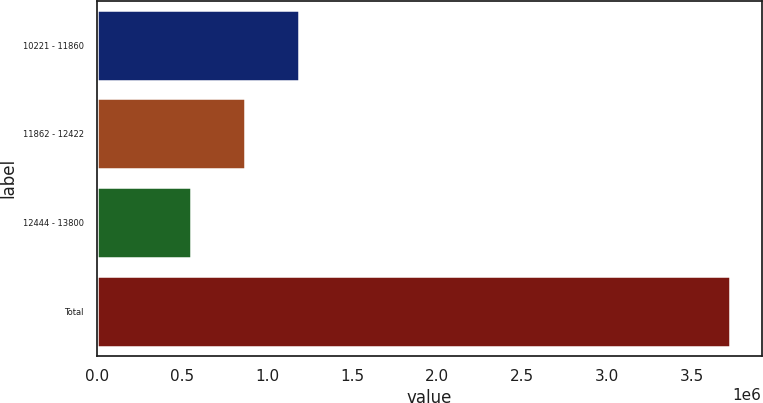<chart> <loc_0><loc_0><loc_500><loc_500><bar_chart><fcel>10221 - 11860<fcel>11862 - 12422<fcel>12444 - 13800<fcel>Total<nl><fcel>1.18681e+06<fcel>869637<fcel>552466<fcel>3.72418e+06<nl></chart> 